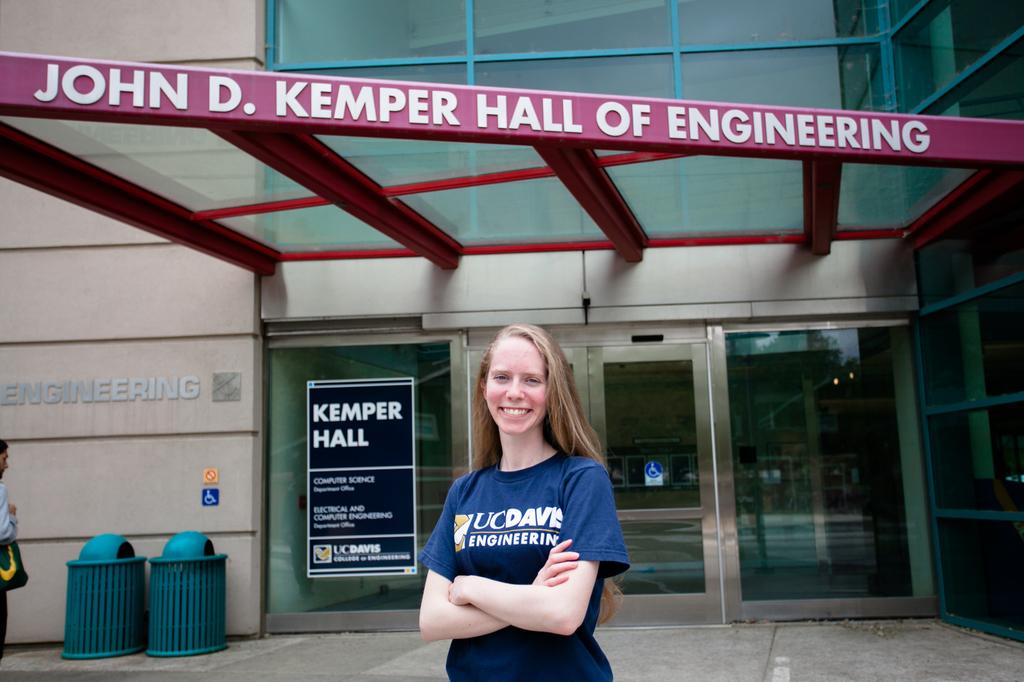Is the lady a student in the hall of engineering?
Make the answer very short. Yes. Is that kemper hall i am seeing there?
Ensure brevity in your answer.  Yes. 